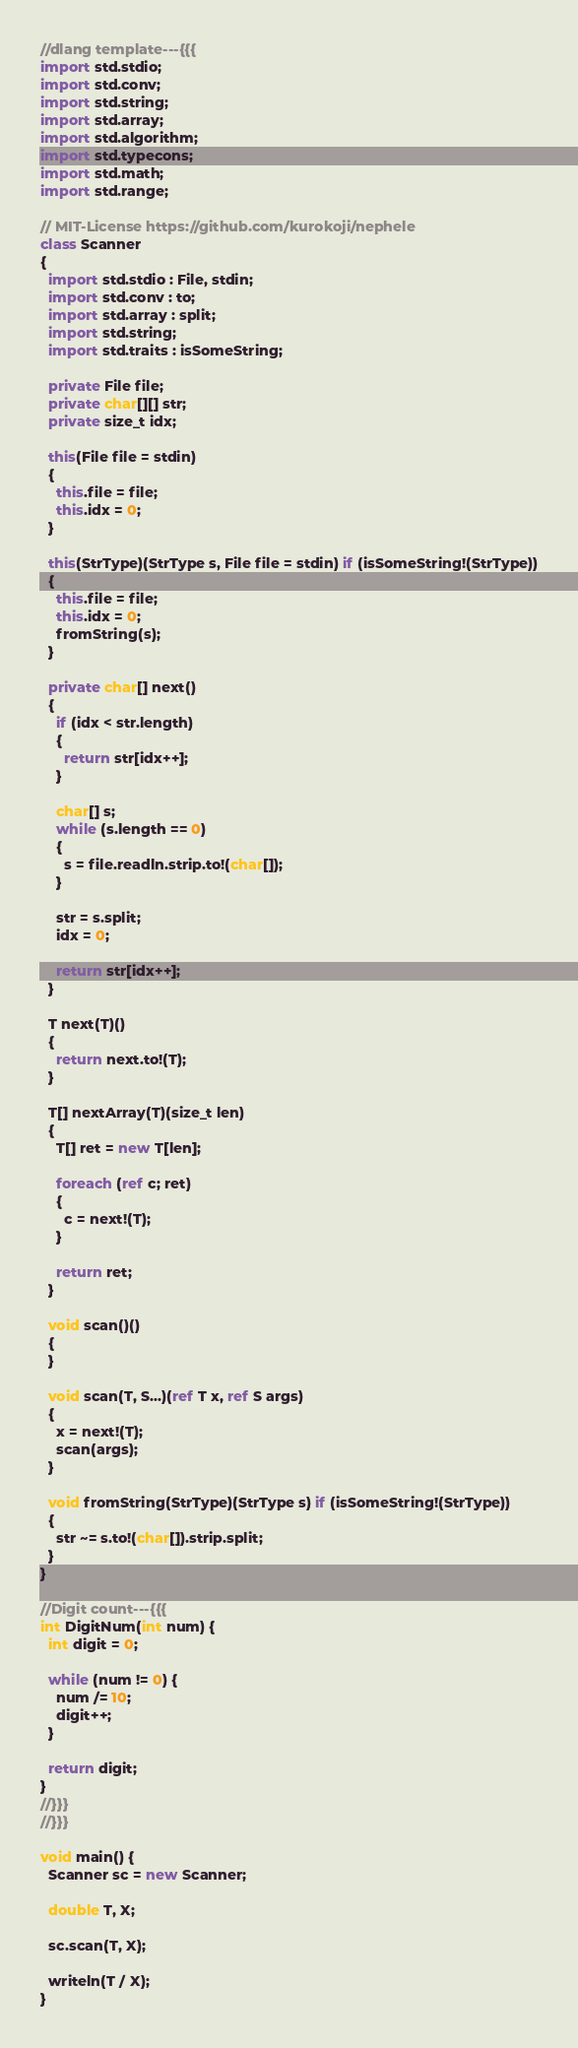<code> <loc_0><loc_0><loc_500><loc_500><_D_>//dlang template---{{{
import std.stdio;
import std.conv;
import std.string;
import std.array;
import std.algorithm;
import std.typecons;
import std.math;
import std.range;

// MIT-License https://github.com/kurokoji/nephele
class Scanner
{
  import std.stdio : File, stdin;
  import std.conv : to;
  import std.array : split;
  import std.string;
  import std.traits : isSomeString;

  private File file;
  private char[][] str;
  private size_t idx;

  this(File file = stdin)
  {
    this.file = file;
    this.idx = 0;
  }

  this(StrType)(StrType s, File file = stdin) if (isSomeString!(StrType))
  {
    this.file = file;
    this.idx = 0;
    fromString(s);
  }

  private char[] next()
  {
    if (idx < str.length)
    {
      return str[idx++];
    }

    char[] s;
    while (s.length == 0)
    {
      s = file.readln.strip.to!(char[]);
    }

    str = s.split;
    idx = 0;

    return str[idx++];
  }

  T next(T)()
  {
    return next.to!(T);
  }

  T[] nextArray(T)(size_t len)
  {
    T[] ret = new T[len];

    foreach (ref c; ret)
    {
      c = next!(T);
    }

    return ret;
  }

  void scan()()
  {
  }

  void scan(T, S...)(ref T x, ref S args)
  {
    x = next!(T);
    scan(args);
  }

  void fromString(StrType)(StrType s) if (isSomeString!(StrType))
  {
    str ~= s.to!(char[]).strip.split;
  }
}

//Digit count---{{{
int DigitNum(int num) {
  int digit = 0;

  while (num != 0) {
    num /= 10;
    digit++;
  }

  return digit;
}
//}}}
//}}}

void main() {
  Scanner sc = new Scanner;

  double T, X;

  sc.scan(T, X);

  writeln(T / X);
}
</code> 